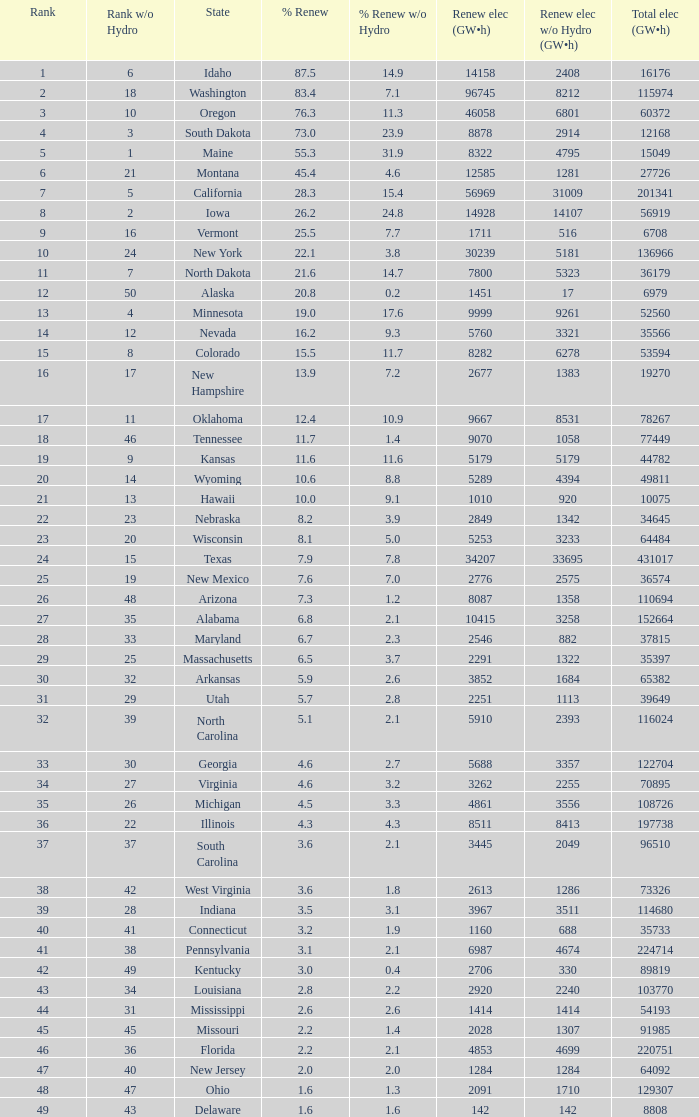Which states have renewable electricity equal to 9667 (gw×h)? Oklahoma. 